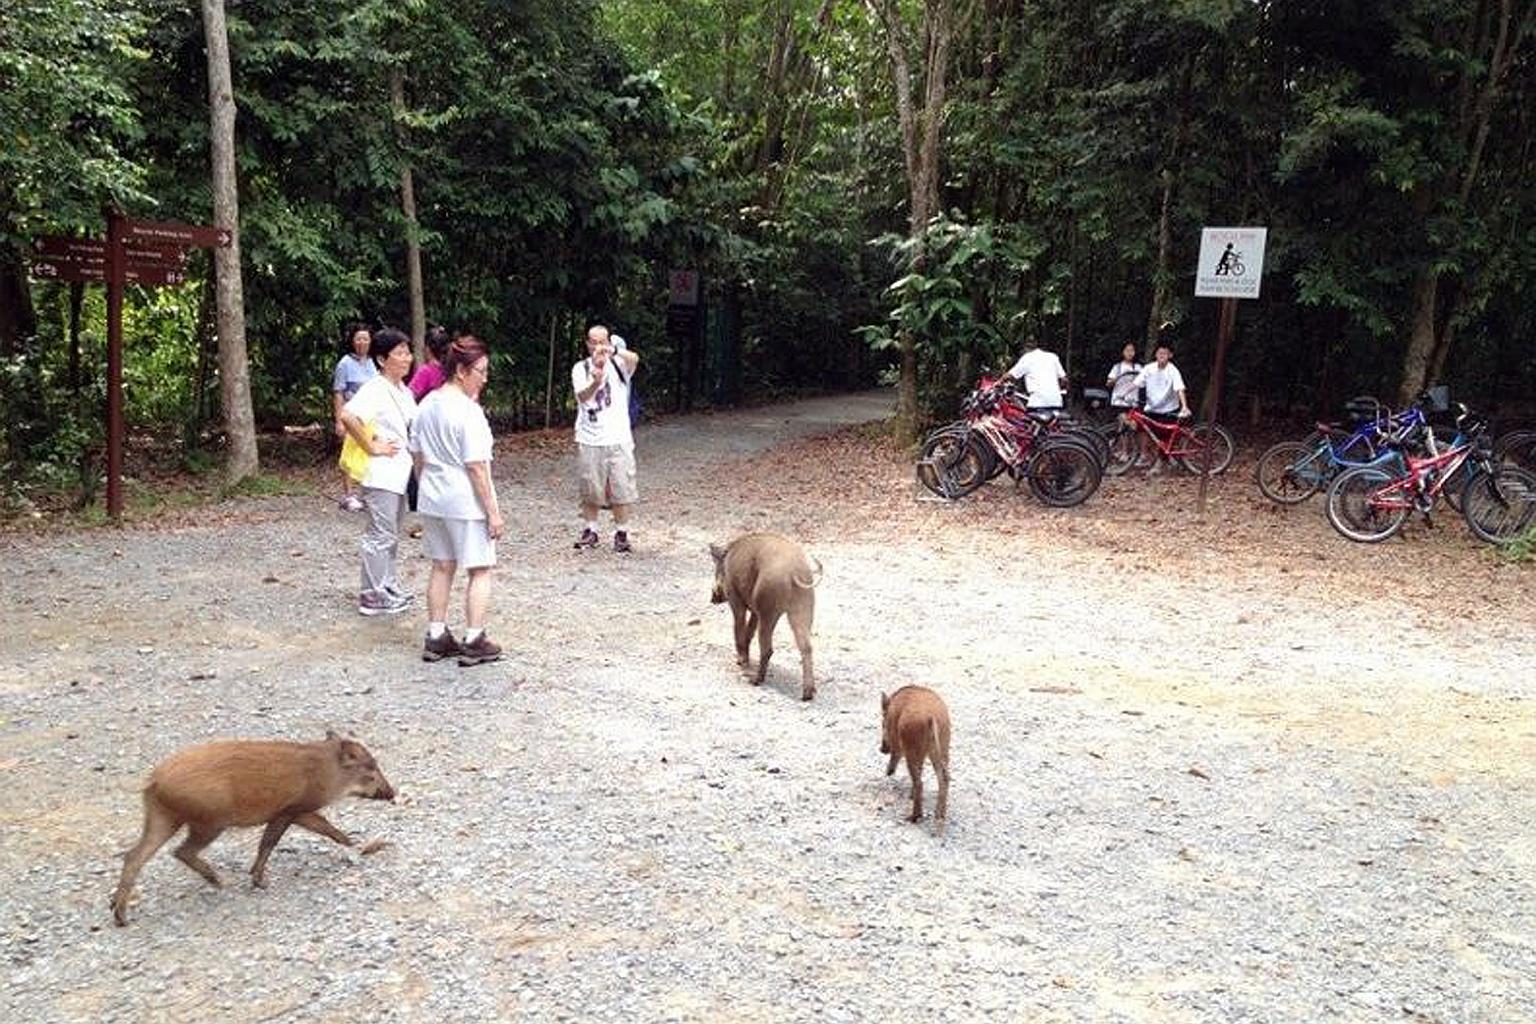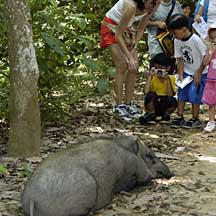The first image is the image on the left, the second image is the image on the right. Considering the images on both sides, is "There is a hog standing in the grass in the left image" valid? Answer yes or no. No. The first image is the image on the left, the second image is the image on the right. Considering the images on both sides, is "A single warthog is facing to the right while standing on green grass in one of the images.." valid? Answer yes or no. No. 